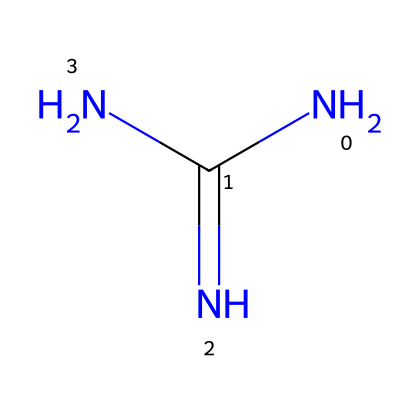What is the molecular formula of guanidine? The SMILES representation indicates the arrangement of atoms in the molecule, which includes 1 nitrogen from the amine group, 2 additional nitrogen atoms from the guanidine structure, and 1 carbon atom, totaling to a molecular formula of C1H1N3.
Answer: C1H1N3 How many nitrogen atoms are present in guanidine? Analyzing the SMILES structure, there are three nitrogen atoms connected to the central carbon atom, seen clearly in the molecular structure provided.
Answer: 3 What type of chemical bond connects the nitrogen atoms to the carbon atom? Looking at the SMILES structure, the nitrogen atoms are connected to the carbon atom through single covalent bonds, identifiable by their respective arrangements and the nature of the atoms involved.
Answer: single covalent bonds Is guanidine a neutral molecule? Considering the structure's overall charge balance, the nitrogen atoms maintain an overall neutral charge in the molecular framework, leading to the conclusion that guanidine is neutral.
Answer: yes What functional groups are present in guanidine? The SMILES representation shows the amine functional groups (-NH2) and imine characteristics due to multiple nitrogen atoms attached; thus, guanidine contains primarily amine and imine functional groups.
Answer: amine and imine What effect does guanidine have when used in cleaning products? Guanidine is classified as a superbase, and its high pH nature aids in breaking down organic materials, making it effective in eco-friendly cleaning products, addressing various stains and residues through its strong basic properties.
Answer: strong basic properties 